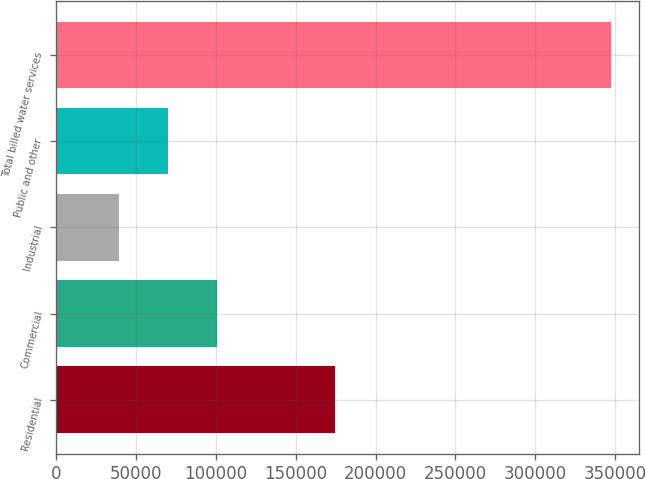<chart> <loc_0><loc_0><loc_500><loc_500><bar_chart><fcel>Residential<fcel>Commercial<fcel>Industrial<fcel>Public and other<fcel>Total billed water services<nl><fcel>174420<fcel>100986<fcel>39404<fcel>70194.8<fcel>347312<nl></chart> 